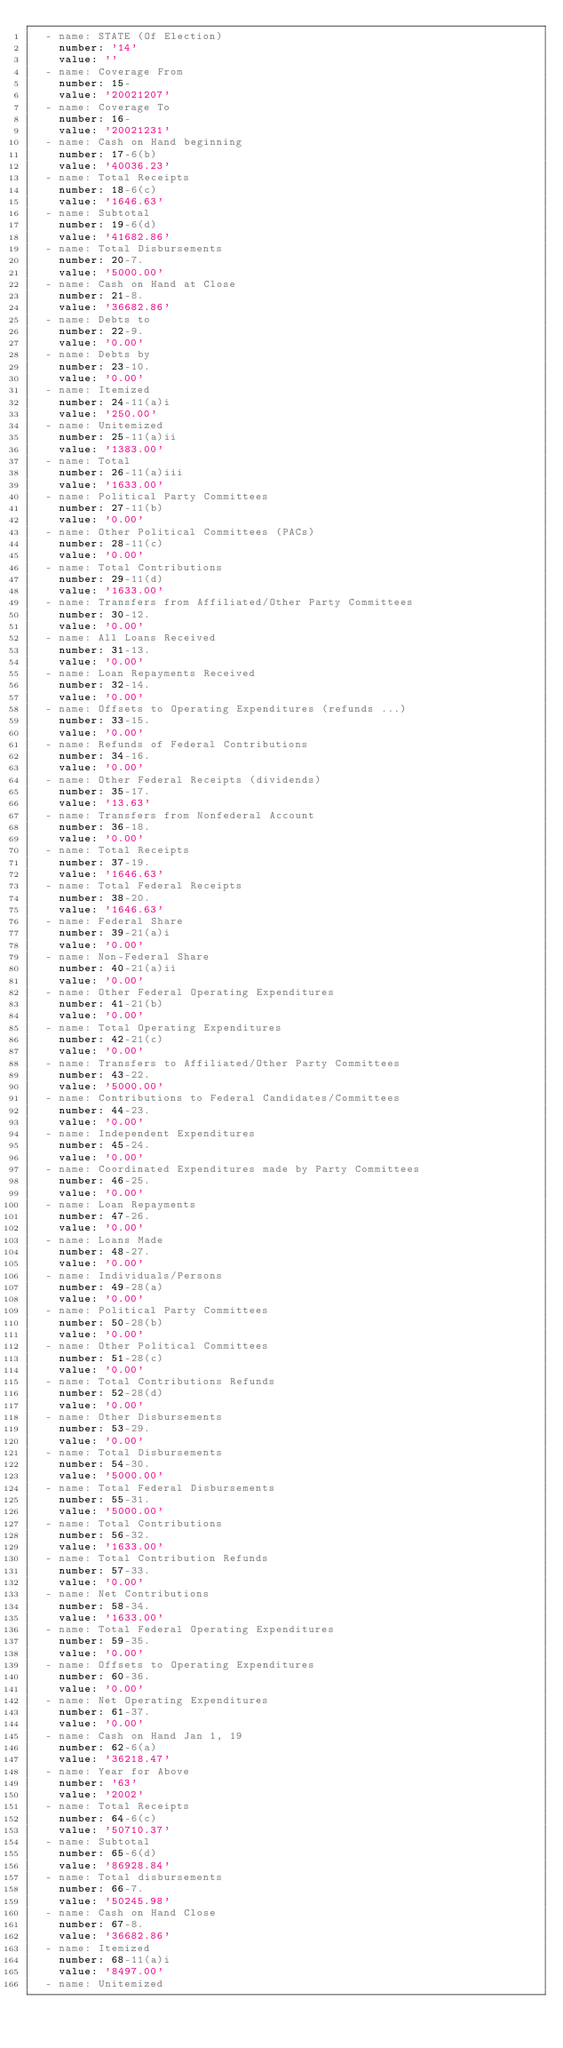<code> <loc_0><loc_0><loc_500><loc_500><_YAML_>  - name: STATE (Of Election)
    number: '14'
    value: ''
  - name: Coverage From
    number: 15-
    value: '20021207'
  - name: Coverage To
    number: 16-
    value: '20021231'
  - name: Cash on Hand beginning
    number: 17-6(b)
    value: '40036.23'
  - name: Total Receipts
    number: 18-6(c)
    value: '1646.63'
  - name: Subtotal
    number: 19-6(d)
    value: '41682.86'
  - name: Total Disbursements
    number: 20-7.
    value: '5000.00'
  - name: Cash on Hand at Close
    number: 21-8.
    value: '36682.86'
  - name: Debts to
    number: 22-9.
    value: '0.00'
  - name: Debts by
    number: 23-10.
    value: '0.00'
  - name: Itemized
    number: 24-11(a)i
    value: '250.00'
  - name: Unitemized
    number: 25-11(a)ii
    value: '1383.00'
  - name: Total
    number: 26-11(a)iii
    value: '1633.00'
  - name: Political Party Committees
    number: 27-11(b)
    value: '0.00'
  - name: Other Political Committees (PACs)
    number: 28-11(c)
    value: '0.00'
  - name: Total Contributions
    number: 29-11(d)
    value: '1633.00'
  - name: Transfers from Affiliated/Other Party Committees
    number: 30-12.
    value: '0.00'
  - name: All Loans Received
    number: 31-13.
    value: '0.00'
  - name: Loan Repayments Received
    number: 32-14.
    value: '0.00'
  - name: Offsets to Operating Expenditures (refunds ...)
    number: 33-15.
    value: '0.00'
  - name: Refunds of Federal Contributions
    number: 34-16.
    value: '0.00'
  - name: Other Federal Receipts (dividends)
    number: 35-17.
    value: '13.63'
  - name: Transfers from Nonfederal Account
    number: 36-18.
    value: '0.00'
  - name: Total Receipts
    number: 37-19.
    value: '1646.63'
  - name: Total Federal Receipts
    number: 38-20.
    value: '1646.63'
  - name: Federal Share
    number: 39-21(a)i
    value: '0.00'
  - name: Non-Federal Share
    number: 40-21(a)ii
    value: '0.00'
  - name: Other Federal Operating Expenditures
    number: 41-21(b)
    value: '0.00'
  - name: Total Operating Expenditures
    number: 42-21(c)
    value: '0.00'
  - name: Transfers to Affiliated/Other Party Committees
    number: 43-22.
    value: '5000.00'
  - name: Contributions to Federal Candidates/Committees
    number: 44-23.
    value: '0.00'
  - name: Independent Expenditures
    number: 45-24.
    value: '0.00'
  - name: Coordinated Expenditures made by Party Committees
    number: 46-25.
    value: '0.00'
  - name: Loan Repayments
    number: 47-26.
    value: '0.00'
  - name: Loans Made
    number: 48-27.
    value: '0.00'
  - name: Individuals/Persons
    number: 49-28(a)
    value: '0.00'
  - name: Political Party Committees
    number: 50-28(b)
    value: '0.00'
  - name: Other Political Committees
    number: 51-28(c)
    value: '0.00'
  - name: Total Contributions Refunds
    number: 52-28(d)
    value: '0.00'
  - name: Other Disbursements
    number: 53-29.
    value: '0.00'
  - name: Total Disbursements
    number: 54-30.
    value: '5000.00'
  - name: Total Federal Disbursements
    number: 55-31.
    value: '5000.00'
  - name: Total Contributions
    number: 56-32.
    value: '1633.00'
  - name: Total Contribution Refunds
    number: 57-33.
    value: '0.00'
  - name: Net Contributions
    number: 58-34.
    value: '1633.00'
  - name: Total Federal Operating Expenditures
    number: 59-35.
    value: '0.00'
  - name: Offsets to Operating Expenditures
    number: 60-36.
    value: '0.00'
  - name: Net Operating Expenditures
    number: 61-37.
    value: '0.00'
  - name: Cash on Hand Jan 1, 19
    number: 62-6(a)
    value: '36218.47'
  - name: Year for Above
    number: '63'
    value: '2002'
  - name: Total Receipts
    number: 64-6(c)
    value: '50710.37'
  - name: Subtotal
    number: 65-6(d)
    value: '86928.84'
  - name: Total disbursements
    number: 66-7.
    value: '50245.98'
  - name: Cash on Hand Close
    number: 67-8.
    value: '36682.86'
  - name: Itemized
    number: 68-11(a)i
    value: '8497.00'
  - name: Unitemized</code> 